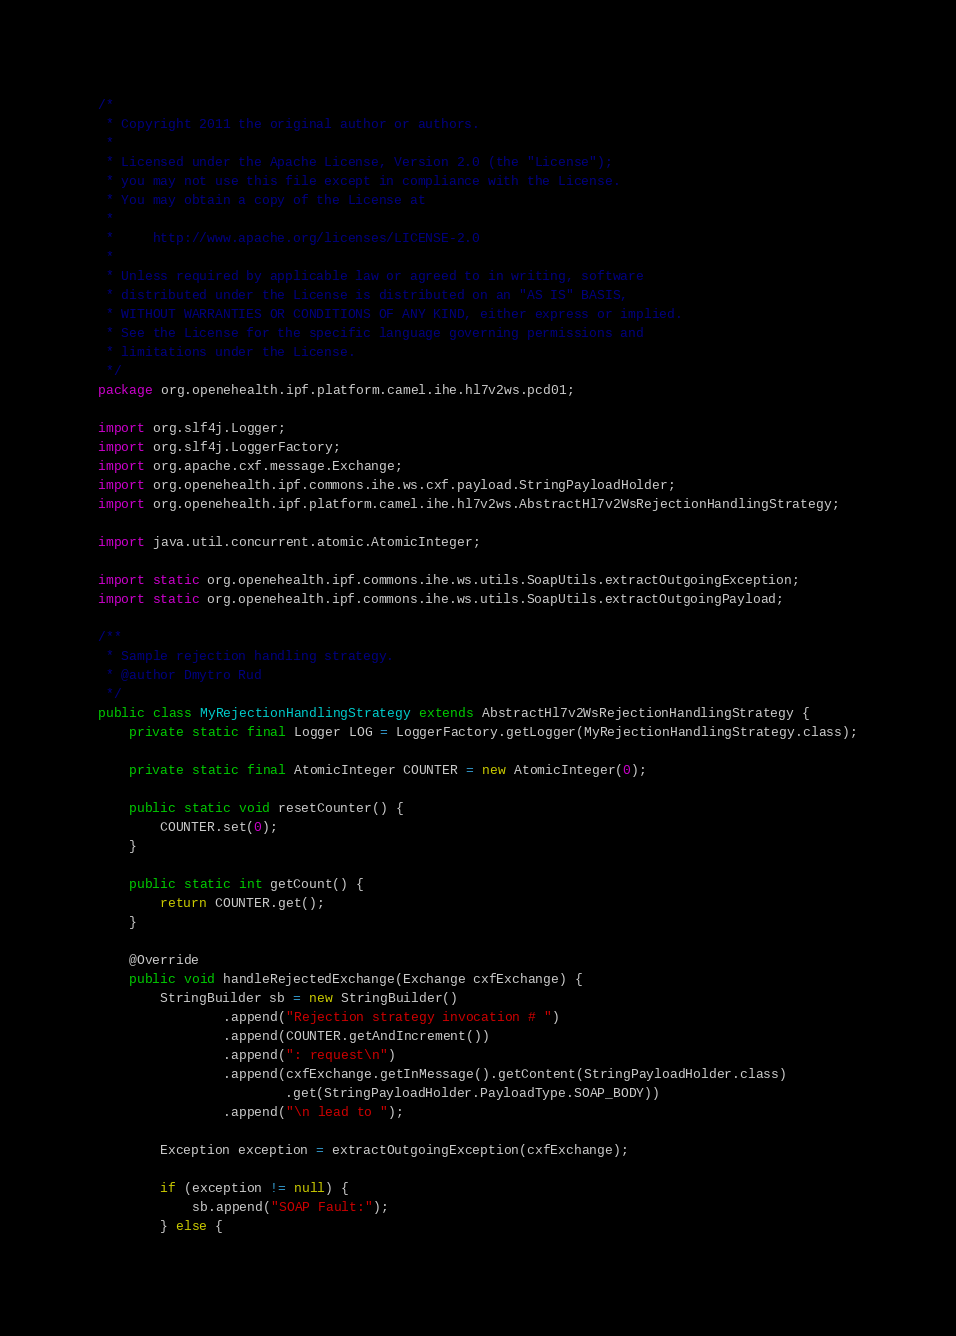<code> <loc_0><loc_0><loc_500><loc_500><_Java_>/*
 * Copyright 2011 the original author or authors.
 *
 * Licensed under the Apache License, Version 2.0 (the "License");
 * you may not use this file except in compliance with the License.
 * You may obtain a copy of the License at
 *
 *     http://www.apache.org/licenses/LICENSE-2.0
 *
 * Unless required by applicable law or agreed to in writing, software
 * distributed under the License is distributed on an "AS IS" BASIS,
 * WITHOUT WARRANTIES OR CONDITIONS OF ANY KIND, either express or implied.
 * See the License for the specific language governing permissions and
 * limitations under the License.
 */
package org.openehealth.ipf.platform.camel.ihe.hl7v2ws.pcd01;

import org.slf4j.Logger;
import org.slf4j.LoggerFactory;
import org.apache.cxf.message.Exchange;
import org.openehealth.ipf.commons.ihe.ws.cxf.payload.StringPayloadHolder;
import org.openehealth.ipf.platform.camel.ihe.hl7v2ws.AbstractHl7v2WsRejectionHandlingStrategy;

import java.util.concurrent.atomic.AtomicInteger;

import static org.openehealth.ipf.commons.ihe.ws.utils.SoapUtils.extractOutgoingException;
import static org.openehealth.ipf.commons.ihe.ws.utils.SoapUtils.extractOutgoingPayload;

/**
 * Sample rejection handling strategy.
 * @author Dmytro Rud
 */
public class MyRejectionHandlingStrategy extends AbstractHl7v2WsRejectionHandlingStrategy {
    private static final Logger LOG = LoggerFactory.getLogger(MyRejectionHandlingStrategy.class);

    private static final AtomicInteger COUNTER = new AtomicInteger(0);

    public static void resetCounter() {
        COUNTER.set(0);
    }

    public static int getCount() {
        return COUNTER.get();
    }

    @Override
    public void handleRejectedExchange(Exchange cxfExchange) {
        StringBuilder sb = new StringBuilder()
                .append("Rejection strategy invocation # ")
                .append(COUNTER.getAndIncrement())
                .append(": request\n")
                .append(cxfExchange.getInMessage().getContent(StringPayloadHolder.class)
                        .get(StringPayloadHolder.PayloadType.SOAP_BODY))
                .append("\n lead to ");

        Exception exception = extractOutgoingException(cxfExchange);

        if (exception != null) {
            sb.append("SOAP Fault:");
        } else {</code> 